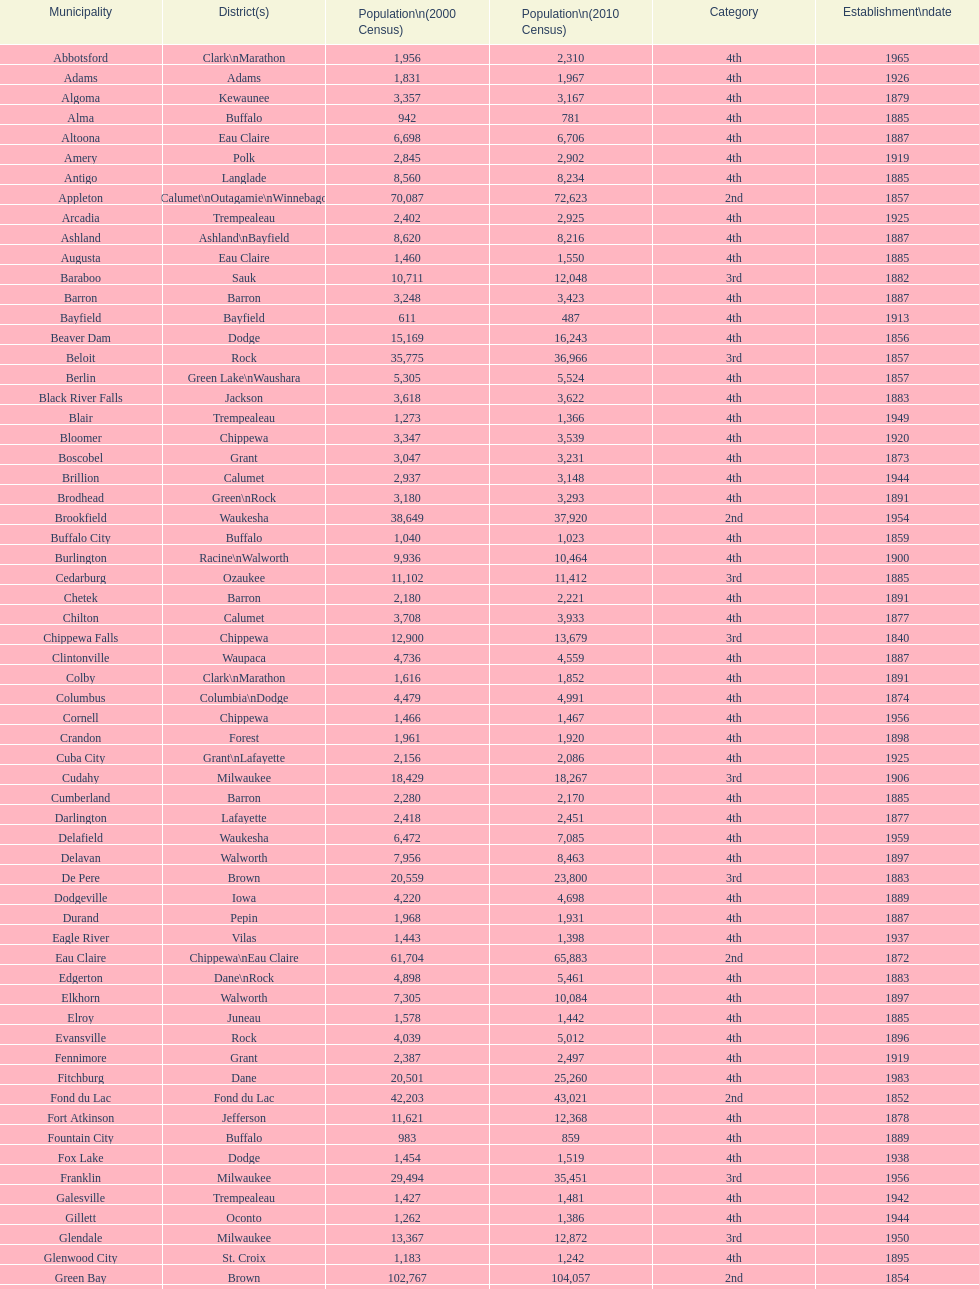Which city has the most population in the 2010 census? Milwaukee. 